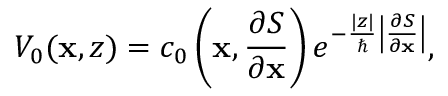<formula> <loc_0><loc_0><loc_500><loc_500>V _ { 0 } ( x , z ) = c _ { 0 } \left ( x , \frac { \partial S } { \partial x } \right ) e ^ { - \frac { | z | } { } \left | \frac { \partial S } { \partial x } \right | } ,</formula> 